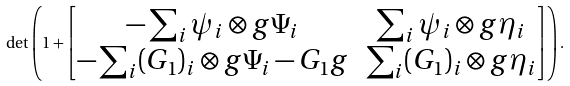<formula> <loc_0><loc_0><loc_500><loc_500>\det \left ( 1 + \begin{bmatrix} - \sum _ { i } \psi _ { i } \otimes g \Psi _ { i } & \sum _ { i } \psi _ { i } \otimes g \eta _ { i } \\ - \sum _ { i } ( G _ { 1 } ) _ { i } \otimes g \Psi _ { i } - G _ { 1 } g & \sum _ { i } ( G _ { 1 } ) _ { i } \otimes g \eta _ { i } \end{bmatrix} \right ) .</formula> 